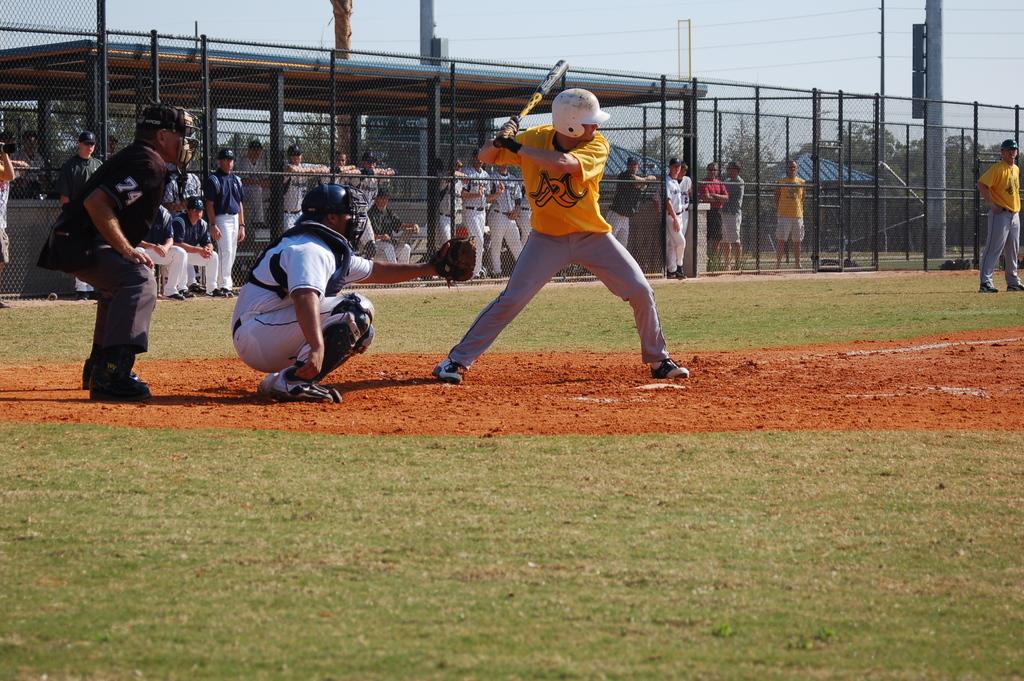What is the number on the sleeve of the catcher?
Your answer should be compact. 74. What number is on the umpire's sleeve?
Your answer should be compact. 74. 